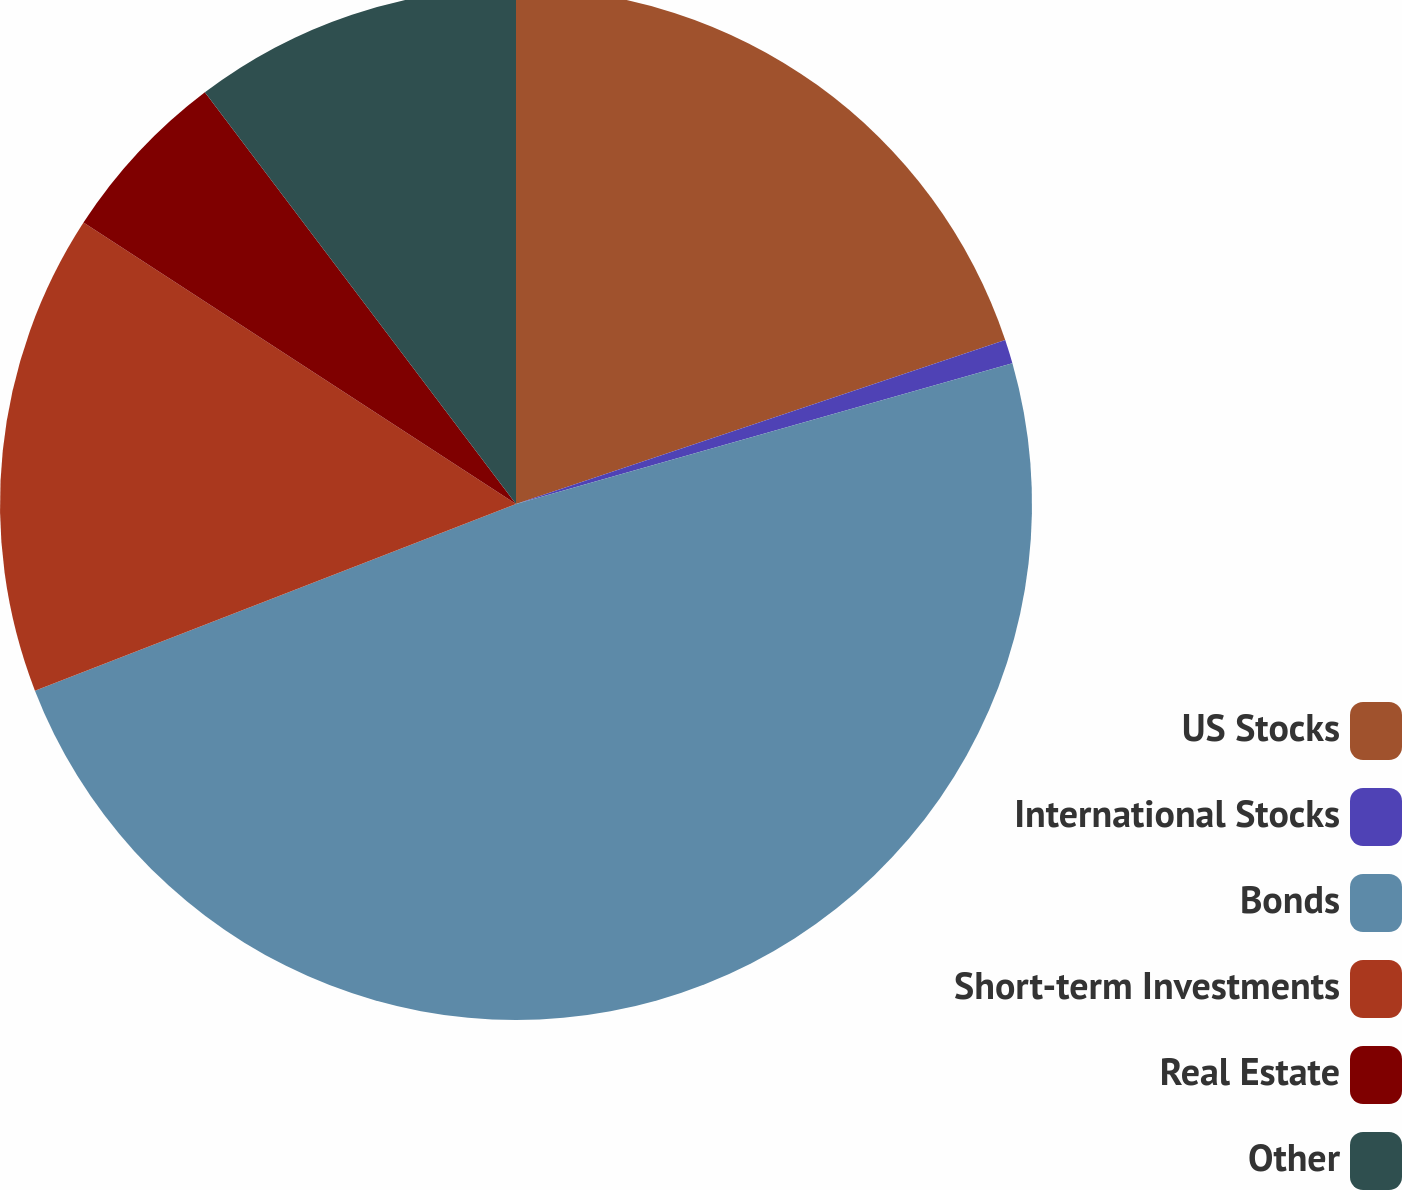<chart> <loc_0><loc_0><loc_500><loc_500><pie_chart><fcel>US Stocks<fcel>International Stocks<fcel>Bonds<fcel>Short-term Investments<fcel>Real Estate<fcel>Other<nl><fcel>19.85%<fcel>0.75%<fcel>48.51%<fcel>15.07%<fcel>5.52%<fcel>10.3%<nl></chart> 